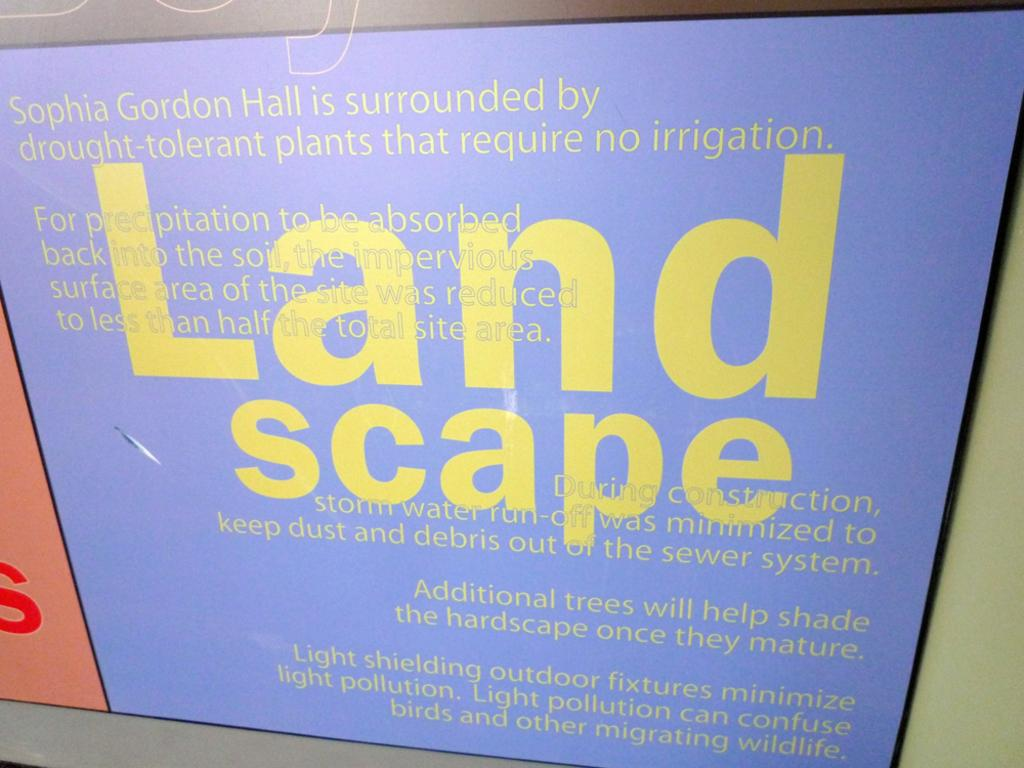<image>
Offer a succinct explanation of the picture presented. And ad display caption of unseen picture that has drought resistant plants 